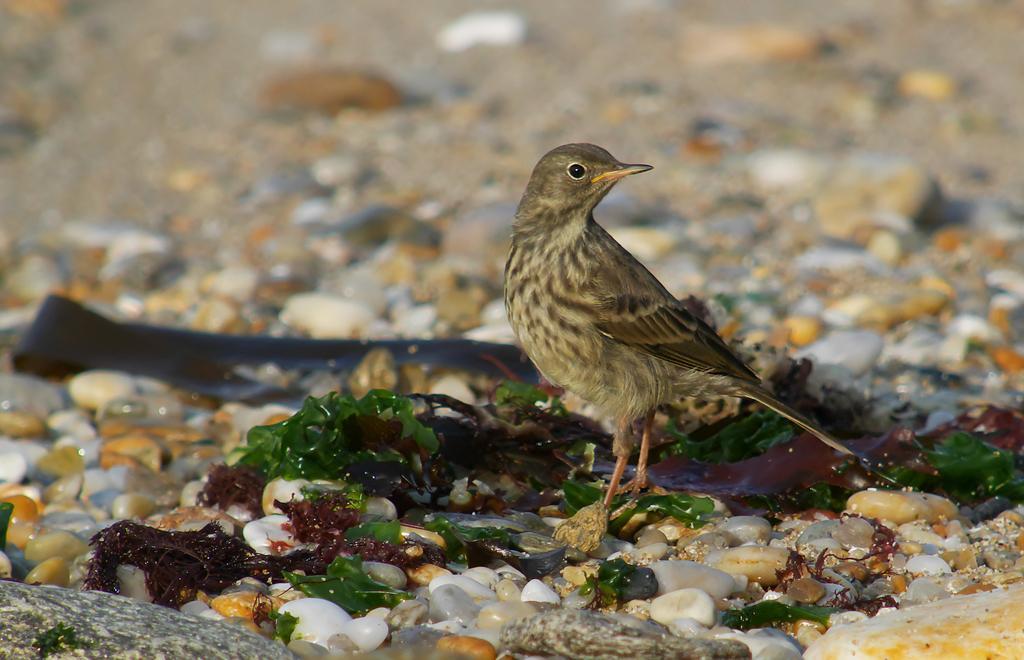In one or two sentences, can you explain what this image depicts? Here there is a bird, these are stones. 